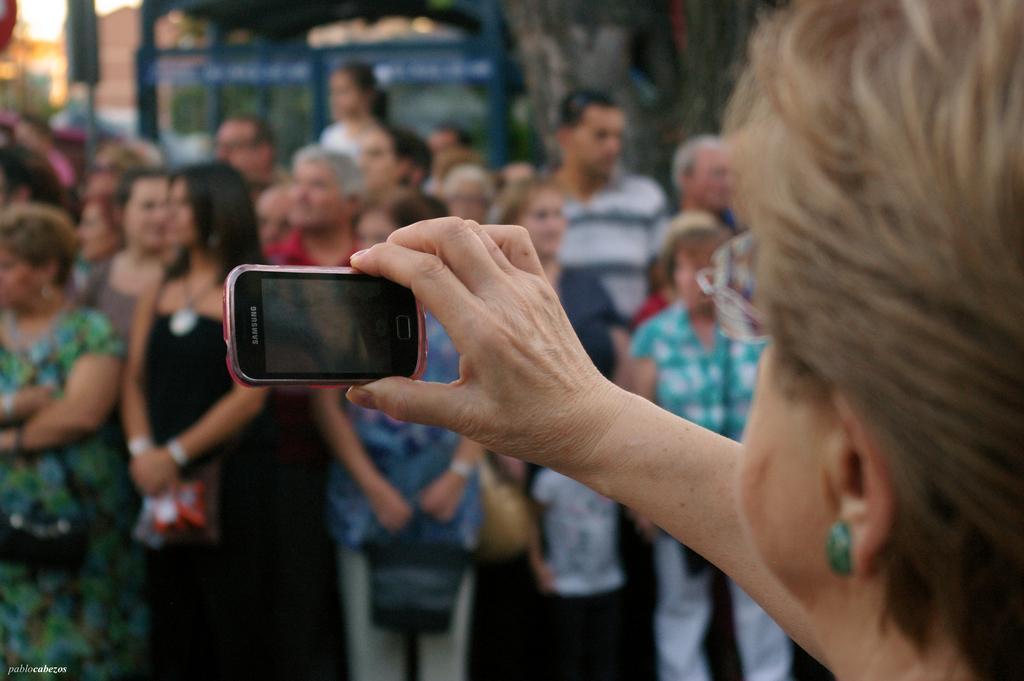Describe this image in one or two sentences. A woman is holding a mobile. There are some people standing in the background. 